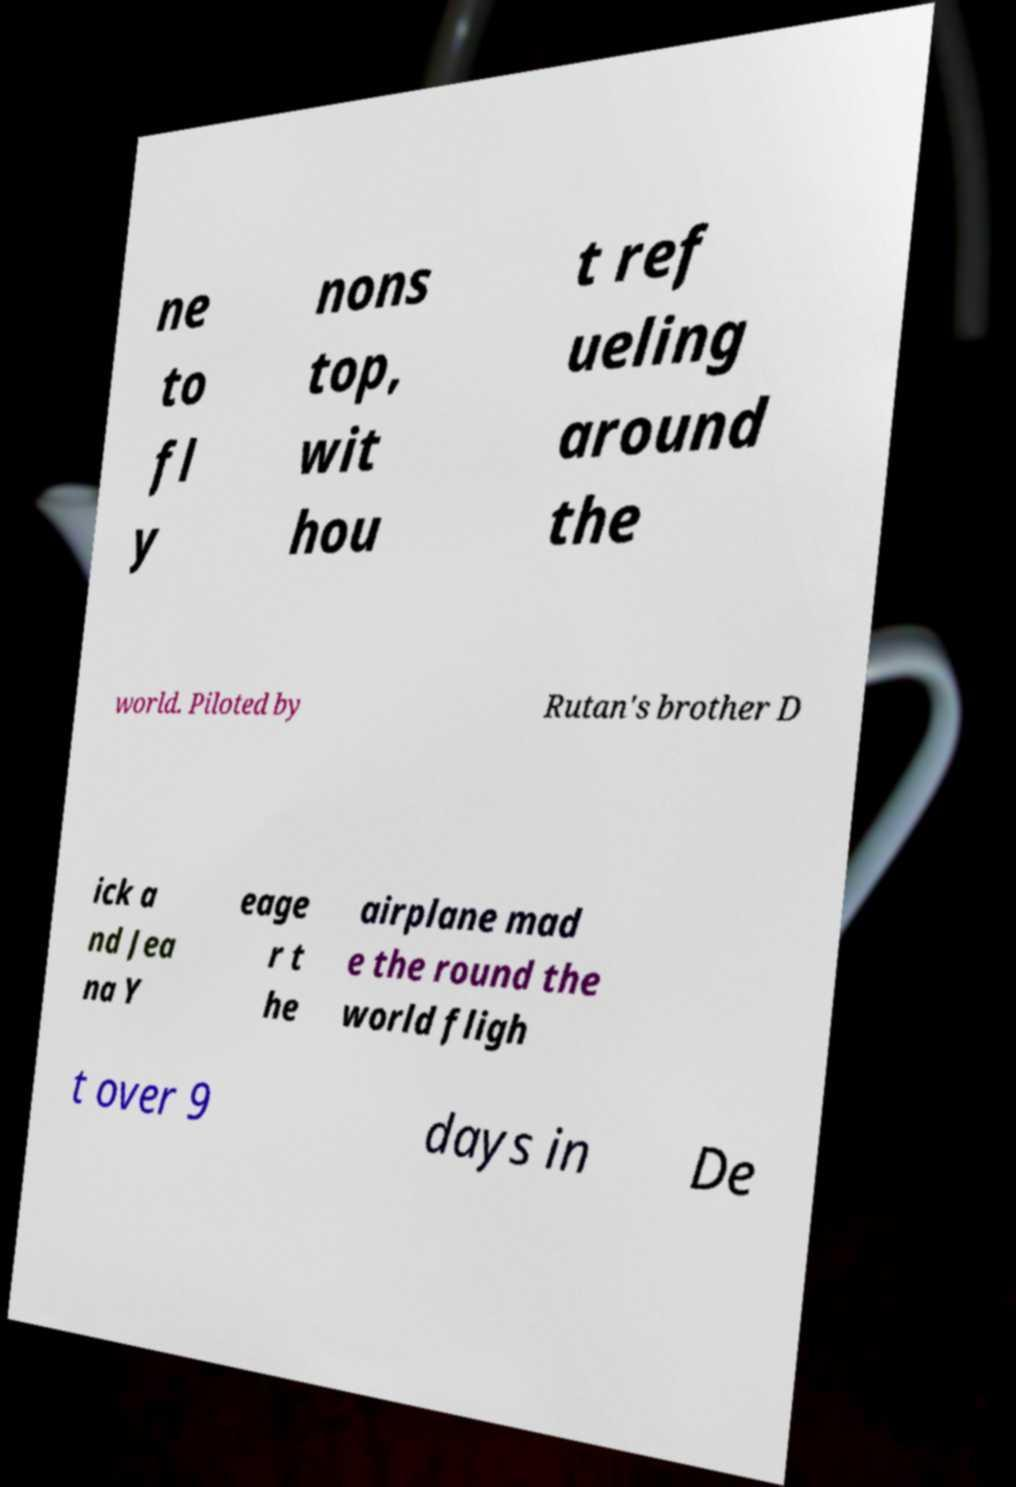What messages or text are displayed in this image? I need them in a readable, typed format. ne to fl y nons top, wit hou t ref ueling around the world. Piloted by Rutan's brother D ick a nd Jea na Y eage r t he airplane mad e the round the world fligh t over 9 days in De 